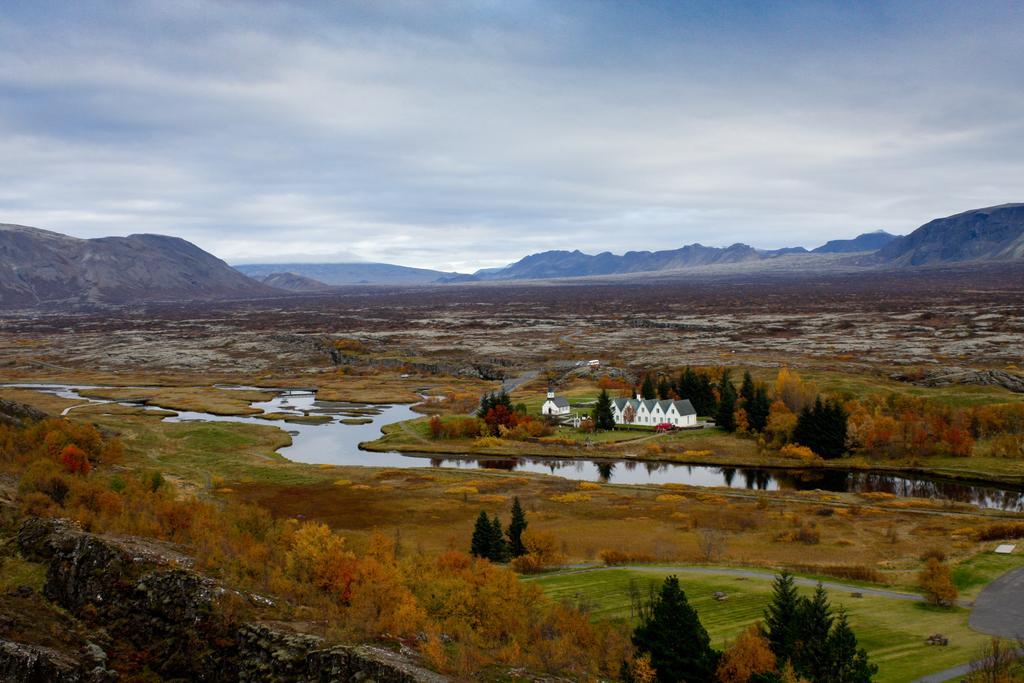In one or two sentences, can you explain what this image depicts? In this image we can see vast land and a river. Behind the river houses and trees are there. Background of the image mountains are present. Bottom of the image trees are there. Top of the image sky is present with clouds. 